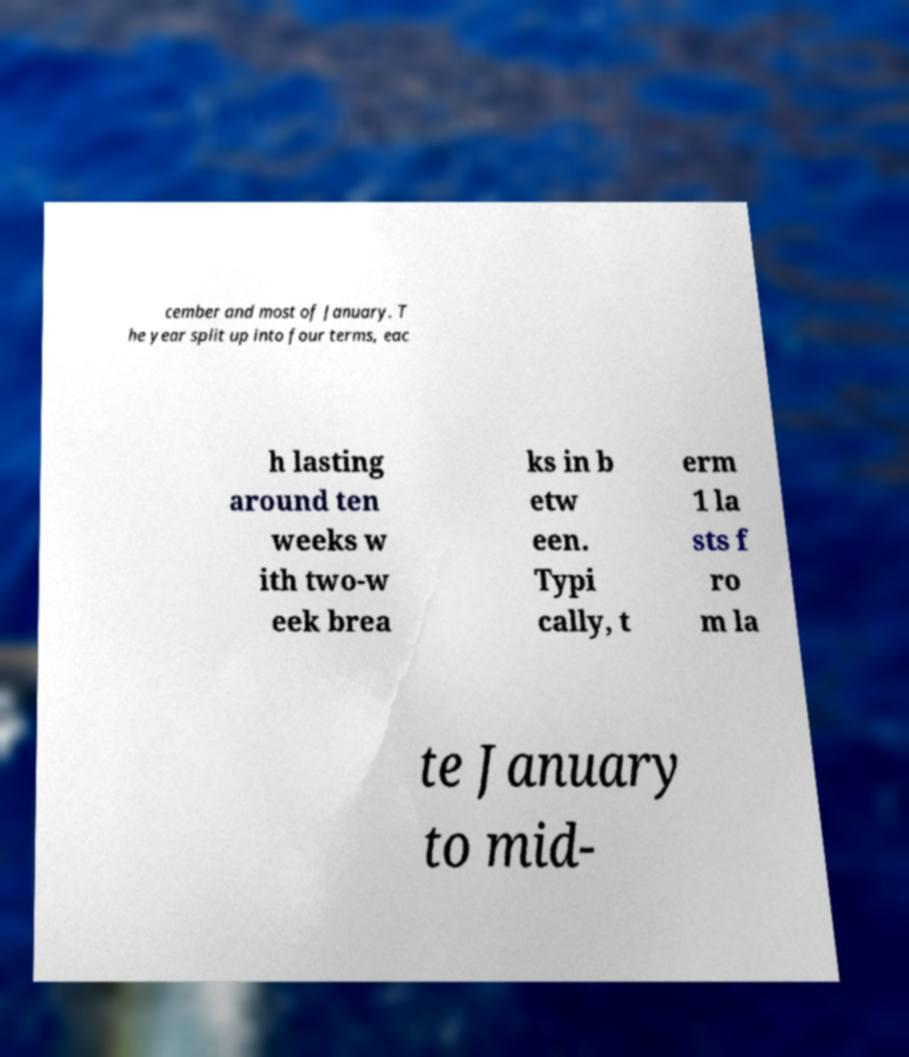Could you extract and type out the text from this image? cember and most of January. T he year split up into four terms, eac h lasting around ten weeks w ith two-w eek brea ks in b etw een. Typi cally, t erm 1 la sts f ro m la te January to mid- 